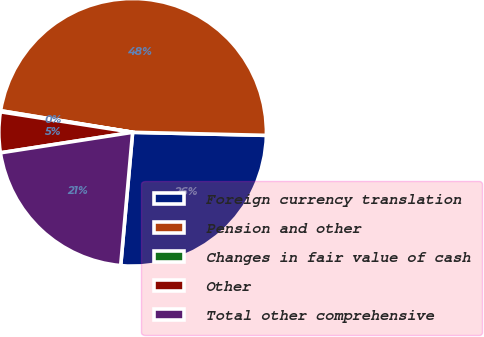Convert chart to OTSL. <chart><loc_0><loc_0><loc_500><loc_500><pie_chart><fcel>Foreign currency translation<fcel>Pension and other<fcel>Changes in fair value of cash<fcel>Other<fcel>Total other comprehensive<nl><fcel>26.06%<fcel>47.79%<fcel>0.13%<fcel>4.9%<fcel>21.13%<nl></chart> 